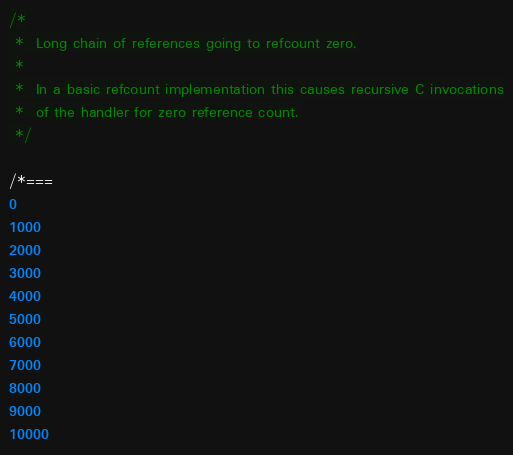<code> <loc_0><loc_0><loc_500><loc_500><_JavaScript_>/*
 *  Long chain of references going to refcount zero.
 *
 *  In a basic refcount implementation this causes recursive C invocations
 *  of the handler for zero reference count.
 */

/*===
0
1000
2000
3000
4000
5000
6000
7000
8000
9000
10000</code> 